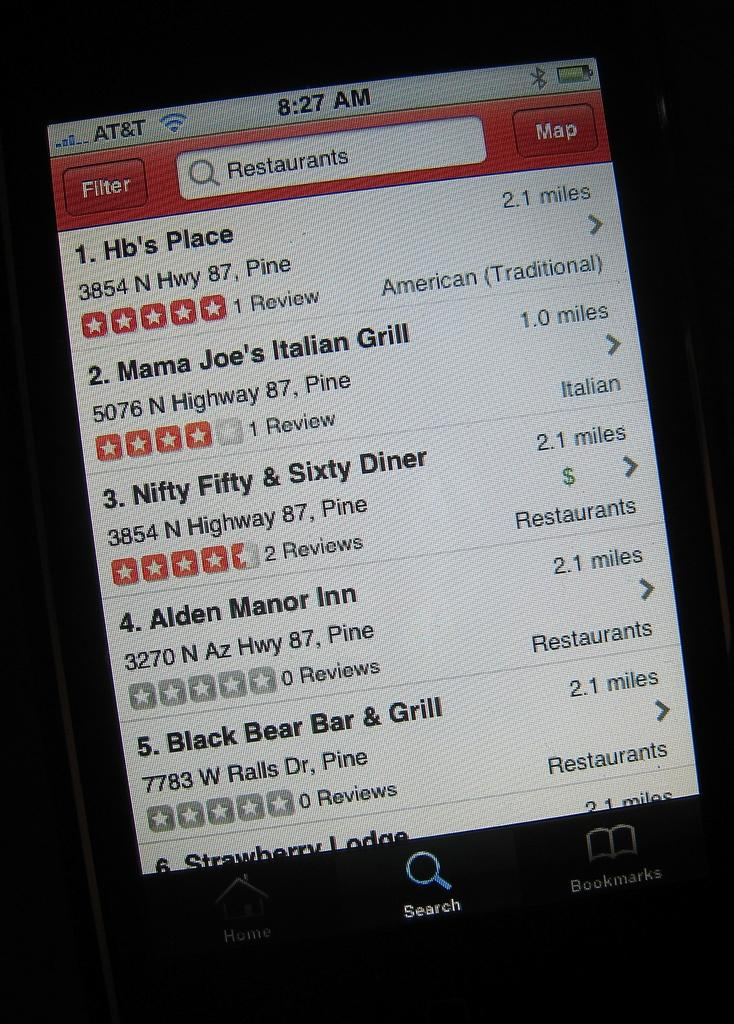<image>
Present a compact description of the photo's key features. A cell phone with a review page displayed. 